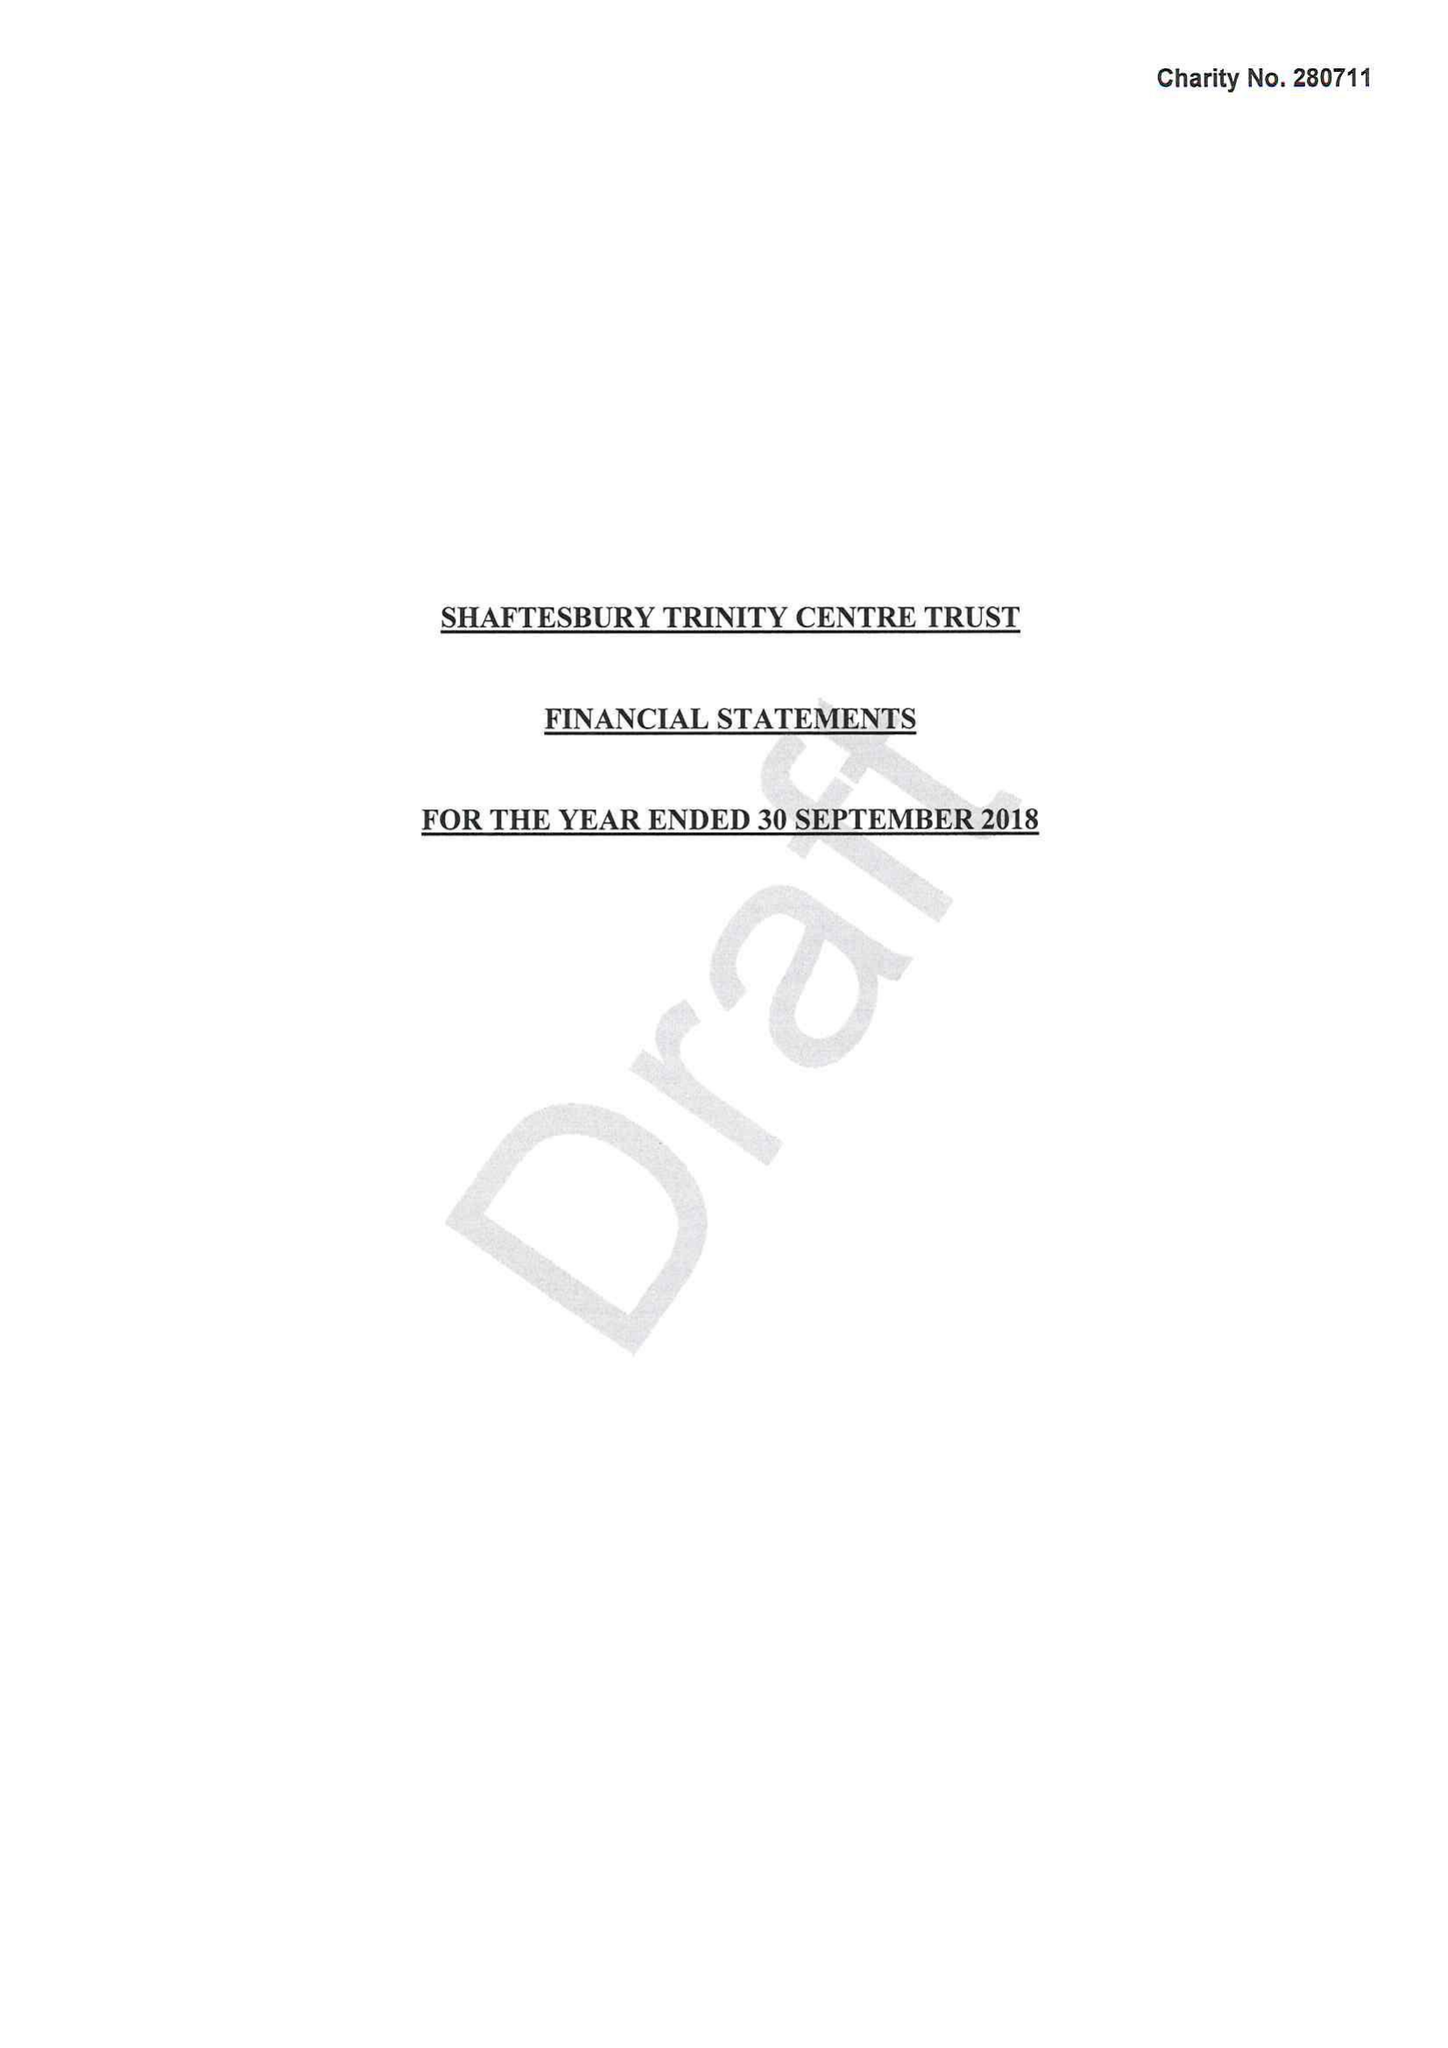What is the value for the address__post_town?
Answer the question using a single word or phrase. GILLINGHAM 